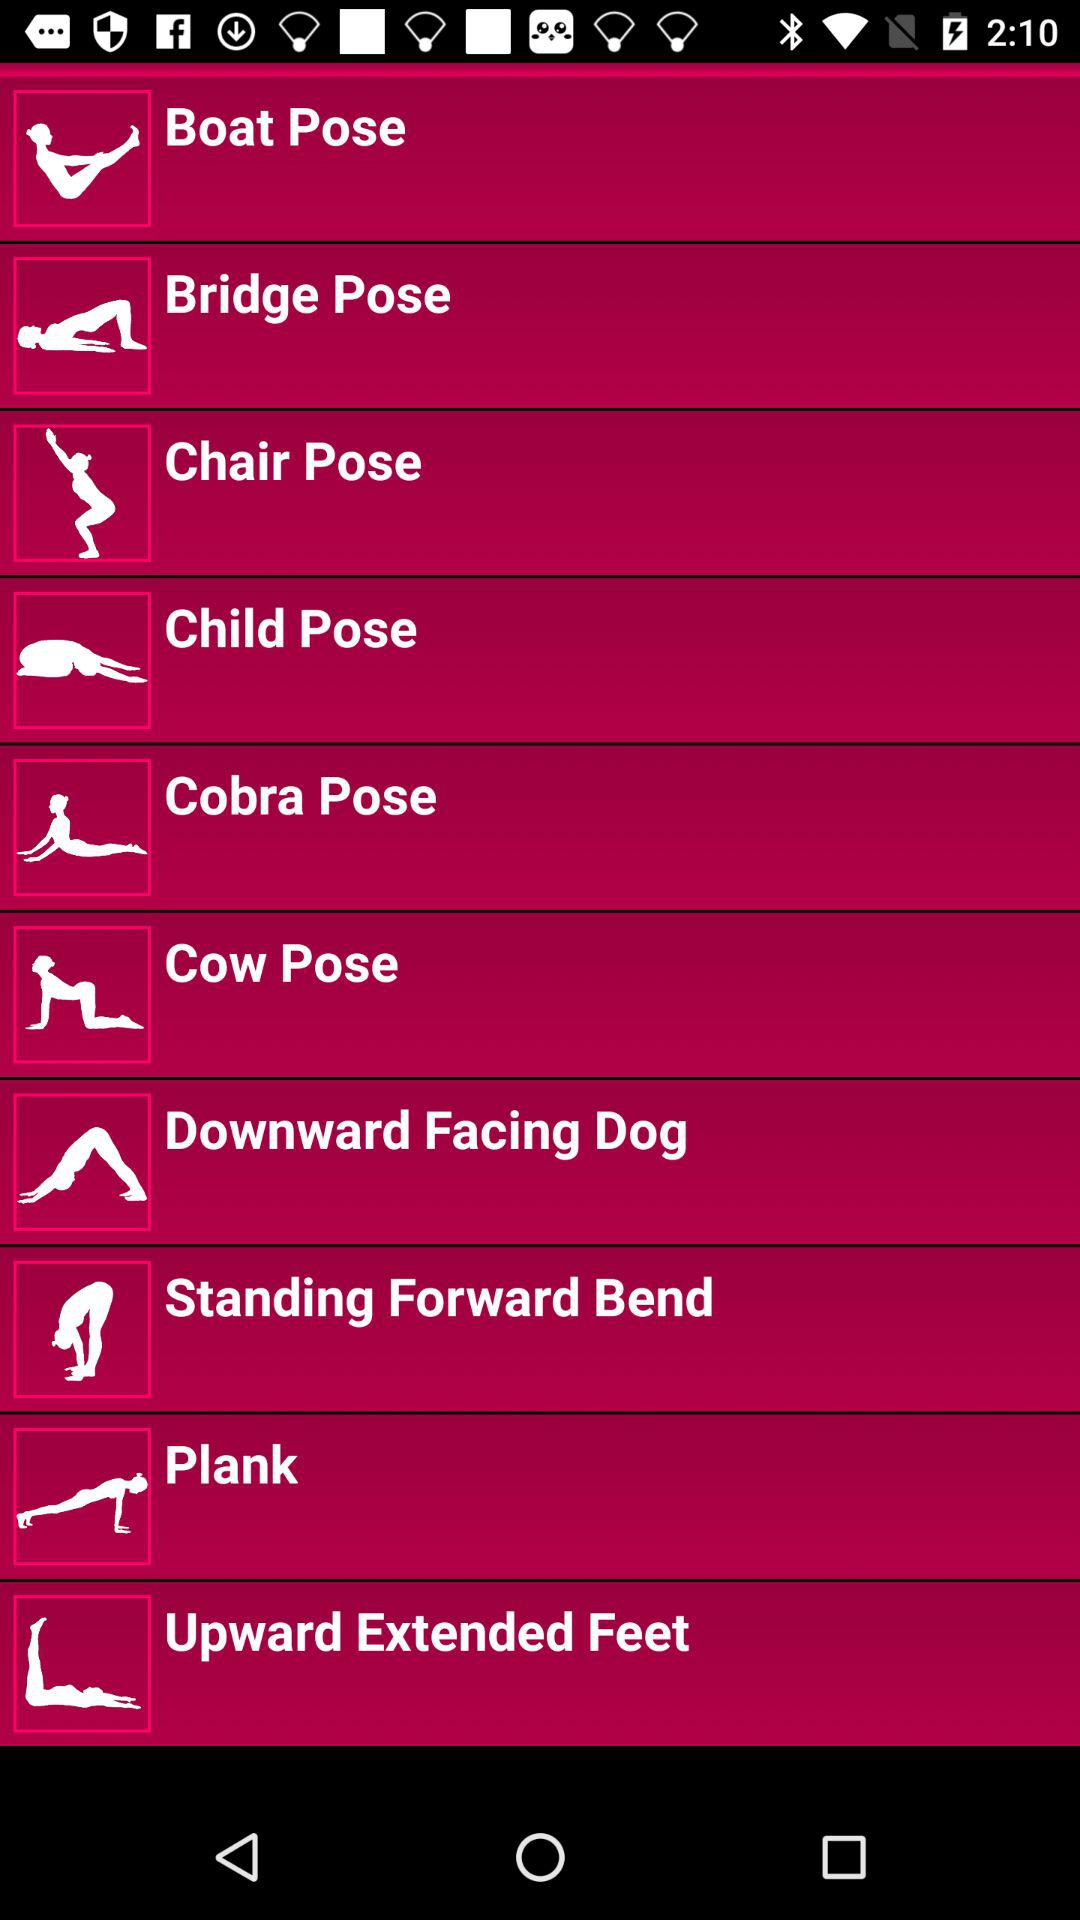What are the different categories of poses available? The different categories of poses available are: "Boat Pose", "Bridge Pose", "Chair Pose", "Child Pose", "Cobra Pose", "Cow Pose", "Downward Facing Dog", "Standing Forward Bend", "Plank", and "Upward Extended Feet". 